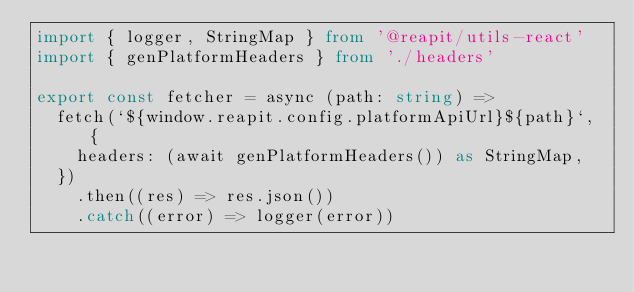Convert code to text. <code><loc_0><loc_0><loc_500><loc_500><_TypeScript_>import { logger, StringMap } from '@reapit/utils-react'
import { genPlatformHeaders } from './headers'

export const fetcher = async (path: string) =>
  fetch(`${window.reapit.config.platformApiUrl}${path}`, {
    headers: (await genPlatformHeaders()) as StringMap,
  })
    .then((res) => res.json())
    .catch((error) => logger(error))
</code> 